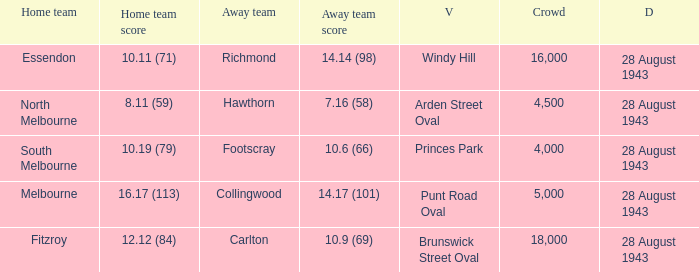I'm looking to parse the entire table for insights. Could you assist me with that? {'header': ['Home team', 'Home team score', 'Away team', 'Away team score', 'V', 'Crowd', 'D'], 'rows': [['Essendon', '10.11 (71)', 'Richmond', '14.14 (98)', 'Windy Hill', '16,000', '28 August 1943'], ['North Melbourne', '8.11 (59)', 'Hawthorn', '7.16 (58)', 'Arden Street Oval', '4,500', '28 August 1943'], ['South Melbourne', '10.19 (79)', 'Footscray', '10.6 (66)', 'Princes Park', '4,000', '28 August 1943'], ['Melbourne', '16.17 (113)', 'Collingwood', '14.17 (101)', 'Punt Road Oval', '5,000', '28 August 1943'], ['Fitzroy', '12.12 (84)', 'Carlton', '10.9 (69)', 'Brunswick Street Oval', '18,000', '28 August 1943']]} What game showed a home team score of 8.11 (59)? 28 August 1943. 